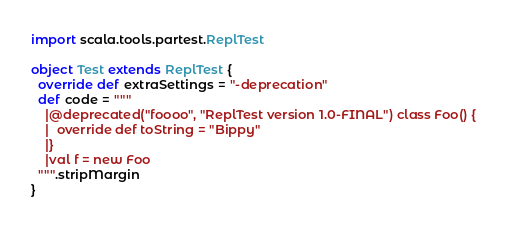Convert code to text. <code><loc_0><loc_0><loc_500><loc_500><_Scala_>import scala.tools.partest.ReplTest

object Test extends ReplTest {
  override def extraSettings = "-deprecation"
  def code = """
    |@deprecated("foooo", "ReplTest version 1.0-FINAL") class Foo() {
    |  override def toString = "Bippy"
    |}
    |val f = new Foo
  """.stripMargin
}
</code> 